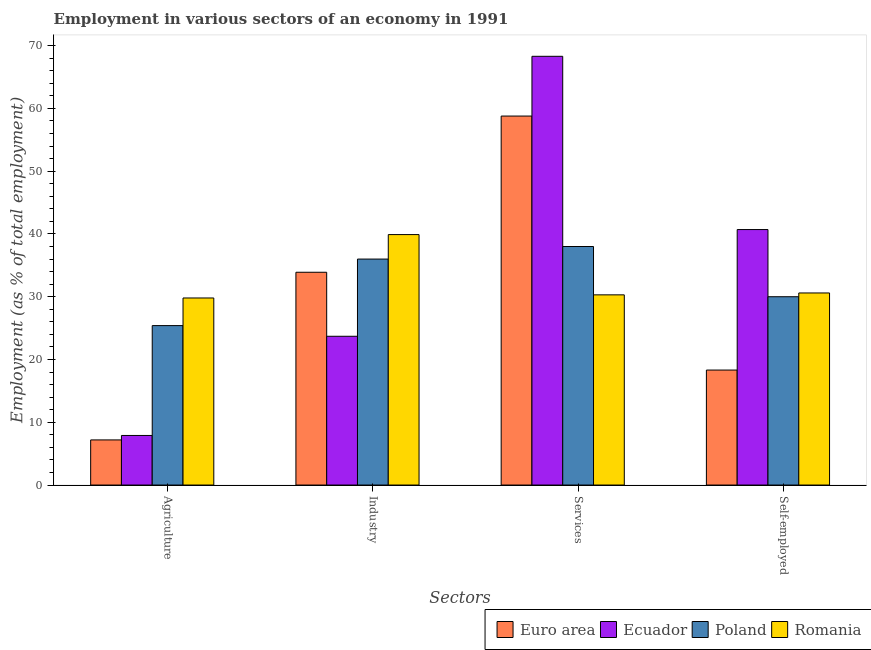Are the number of bars per tick equal to the number of legend labels?
Offer a terse response. Yes. How many bars are there on the 3rd tick from the right?
Keep it short and to the point. 4. What is the label of the 4th group of bars from the left?
Keep it short and to the point. Self-employed. Across all countries, what is the maximum percentage of workers in industry?
Keep it short and to the point. 39.9. Across all countries, what is the minimum percentage of workers in industry?
Provide a short and direct response. 23.7. In which country was the percentage of workers in industry maximum?
Give a very brief answer. Romania. What is the total percentage of workers in industry in the graph?
Keep it short and to the point. 133.5. What is the difference between the percentage of workers in industry in Romania and that in Poland?
Provide a short and direct response. 3.9. What is the difference between the percentage of workers in agriculture in Euro area and the percentage of workers in services in Romania?
Provide a succinct answer. -23.11. What is the average percentage of workers in services per country?
Make the answer very short. 48.85. What is the difference between the percentage of workers in services and percentage of workers in industry in Romania?
Your answer should be very brief. -9.6. In how many countries, is the percentage of self employed workers greater than 44 %?
Make the answer very short. 0. What is the ratio of the percentage of workers in services in Romania to that in Ecuador?
Provide a short and direct response. 0.44. Is the difference between the percentage of workers in services in Poland and Ecuador greater than the difference between the percentage of workers in agriculture in Poland and Ecuador?
Keep it short and to the point. No. What is the difference between the highest and the second highest percentage of workers in industry?
Provide a succinct answer. 3.9. What is the difference between the highest and the lowest percentage of self employed workers?
Your answer should be very brief. 22.38. In how many countries, is the percentage of workers in agriculture greater than the average percentage of workers in agriculture taken over all countries?
Provide a succinct answer. 2. Is the sum of the percentage of workers in agriculture in Euro area and Poland greater than the maximum percentage of workers in industry across all countries?
Your response must be concise. No. What does the 1st bar from the left in Industry represents?
Your answer should be compact. Euro area. What does the 2nd bar from the right in Services represents?
Your answer should be compact. Poland. Is it the case that in every country, the sum of the percentage of workers in agriculture and percentage of workers in industry is greater than the percentage of workers in services?
Keep it short and to the point. No. What is the difference between two consecutive major ticks on the Y-axis?
Provide a succinct answer. 10. Are the values on the major ticks of Y-axis written in scientific E-notation?
Keep it short and to the point. No. Does the graph contain grids?
Your answer should be compact. No. Where does the legend appear in the graph?
Your answer should be very brief. Bottom right. How are the legend labels stacked?
Provide a short and direct response. Horizontal. What is the title of the graph?
Offer a terse response. Employment in various sectors of an economy in 1991. Does "Fragile and conflict affected situations" appear as one of the legend labels in the graph?
Offer a very short reply. No. What is the label or title of the X-axis?
Offer a very short reply. Sectors. What is the label or title of the Y-axis?
Ensure brevity in your answer.  Employment (as % of total employment). What is the Employment (as % of total employment) of Euro area in Agriculture?
Keep it short and to the point. 7.19. What is the Employment (as % of total employment) in Ecuador in Agriculture?
Your answer should be very brief. 7.9. What is the Employment (as % of total employment) in Poland in Agriculture?
Provide a succinct answer. 25.4. What is the Employment (as % of total employment) in Romania in Agriculture?
Offer a terse response. 29.8. What is the Employment (as % of total employment) of Euro area in Industry?
Your answer should be compact. 33.9. What is the Employment (as % of total employment) of Ecuador in Industry?
Provide a short and direct response. 23.7. What is the Employment (as % of total employment) in Romania in Industry?
Keep it short and to the point. 39.9. What is the Employment (as % of total employment) of Euro area in Services?
Make the answer very short. 58.78. What is the Employment (as % of total employment) in Ecuador in Services?
Make the answer very short. 68.3. What is the Employment (as % of total employment) in Romania in Services?
Your answer should be very brief. 30.3. What is the Employment (as % of total employment) in Euro area in Self-employed?
Your answer should be very brief. 18.32. What is the Employment (as % of total employment) of Ecuador in Self-employed?
Provide a succinct answer. 40.7. What is the Employment (as % of total employment) of Poland in Self-employed?
Offer a very short reply. 30. What is the Employment (as % of total employment) in Romania in Self-employed?
Offer a very short reply. 30.6. Across all Sectors, what is the maximum Employment (as % of total employment) in Euro area?
Ensure brevity in your answer.  58.78. Across all Sectors, what is the maximum Employment (as % of total employment) of Ecuador?
Provide a succinct answer. 68.3. Across all Sectors, what is the maximum Employment (as % of total employment) of Poland?
Offer a very short reply. 38. Across all Sectors, what is the maximum Employment (as % of total employment) in Romania?
Provide a short and direct response. 39.9. Across all Sectors, what is the minimum Employment (as % of total employment) of Euro area?
Provide a succinct answer. 7.19. Across all Sectors, what is the minimum Employment (as % of total employment) of Ecuador?
Give a very brief answer. 7.9. Across all Sectors, what is the minimum Employment (as % of total employment) of Poland?
Provide a succinct answer. 25.4. Across all Sectors, what is the minimum Employment (as % of total employment) in Romania?
Your answer should be compact. 29.8. What is the total Employment (as % of total employment) of Euro area in the graph?
Provide a short and direct response. 118.19. What is the total Employment (as % of total employment) in Ecuador in the graph?
Your answer should be very brief. 140.6. What is the total Employment (as % of total employment) in Poland in the graph?
Make the answer very short. 129.4. What is the total Employment (as % of total employment) in Romania in the graph?
Give a very brief answer. 130.6. What is the difference between the Employment (as % of total employment) of Euro area in Agriculture and that in Industry?
Your answer should be very brief. -26.71. What is the difference between the Employment (as % of total employment) of Ecuador in Agriculture and that in Industry?
Your answer should be very brief. -15.8. What is the difference between the Employment (as % of total employment) of Poland in Agriculture and that in Industry?
Make the answer very short. -10.6. What is the difference between the Employment (as % of total employment) of Romania in Agriculture and that in Industry?
Provide a succinct answer. -10.1. What is the difference between the Employment (as % of total employment) in Euro area in Agriculture and that in Services?
Offer a very short reply. -51.59. What is the difference between the Employment (as % of total employment) in Ecuador in Agriculture and that in Services?
Keep it short and to the point. -60.4. What is the difference between the Employment (as % of total employment) in Euro area in Agriculture and that in Self-employed?
Provide a short and direct response. -11.13. What is the difference between the Employment (as % of total employment) of Ecuador in Agriculture and that in Self-employed?
Keep it short and to the point. -32.8. What is the difference between the Employment (as % of total employment) of Poland in Agriculture and that in Self-employed?
Offer a terse response. -4.6. What is the difference between the Employment (as % of total employment) of Romania in Agriculture and that in Self-employed?
Give a very brief answer. -0.8. What is the difference between the Employment (as % of total employment) in Euro area in Industry and that in Services?
Your answer should be very brief. -24.88. What is the difference between the Employment (as % of total employment) of Ecuador in Industry and that in Services?
Ensure brevity in your answer.  -44.6. What is the difference between the Employment (as % of total employment) in Poland in Industry and that in Services?
Provide a succinct answer. -2. What is the difference between the Employment (as % of total employment) of Romania in Industry and that in Services?
Provide a succinct answer. 9.6. What is the difference between the Employment (as % of total employment) of Euro area in Industry and that in Self-employed?
Give a very brief answer. 15.58. What is the difference between the Employment (as % of total employment) in Euro area in Services and that in Self-employed?
Give a very brief answer. 40.46. What is the difference between the Employment (as % of total employment) in Ecuador in Services and that in Self-employed?
Your response must be concise. 27.6. What is the difference between the Employment (as % of total employment) in Euro area in Agriculture and the Employment (as % of total employment) in Ecuador in Industry?
Offer a very short reply. -16.51. What is the difference between the Employment (as % of total employment) of Euro area in Agriculture and the Employment (as % of total employment) of Poland in Industry?
Offer a very short reply. -28.81. What is the difference between the Employment (as % of total employment) in Euro area in Agriculture and the Employment (as % of total employment) in Romania in Industry?
Offer a terse response. -32.71. What is the difference between the Employment (as % of total employment) of Ecuador in Agriculture and the Employment (as % of total employment) of Poland in Industry?
Your answer should be compact. -28.1. What is the difference between the Employment (as % of total employment) of Ecuador in Agriculture and the Employment (as % of total employment) of Romania in Industry?
Provide a succinct answer. -32. What is the difference between the Employment (as % of total employment) in Euro area in Agriculture and the Employment (as % of total employment) in Ecuador in Services?
Your response must be concise. -61.11. What is the difference between the Employment (as % of total employment) in Euro area in Agriculture and the Employment (as % of total employment) in Poland in Services?
Ensure brevity in your answer.  -30.81. What is the difference between the Employment (as % of total employment) in Euro area in Agriculture and the Employment (as % of total employment) in Romania in Services?
Offer a very short reply. -23.11. What is the difference between the Employment (as % of total employment) in Ecuador in Agriculture and the Employment (as % of total employment) in Poland in Services?
Make the answer very short. -30.1. What is the difference between the Employment (as % of total employment) of Ecuador in Agriculture and the Employment (as % of total employment) of Romania in Services?
Make the answer very short. -22.4. What is the difference between the Employment (as % of total employment) of Poland in Agriculture and the Employment (as % of total employment) of Romania in Services?
Provide a succinct answer. -4.9. What is the difference between the Employment (as % of total employment) in Euro area in Agriculture and the Employment (as % of total employment) in Ecuador in Self-employed?
Provide a succinct answer. -33.51. What is the difference between the Employment (as % of total employment) in Euro area in Agriculture and the Employment (as % of total employment) in Poland in Self-employed?
Give a very brief answer. -22.81. What is the difference between the Employment (as % of total employment) in Euro area in Agriculture and the Employment (as % of total employment) in Romania in Self-employed?
Your answer should be very brief. -23.41. What is the difference between the Employment (as % of total employment) in Ecuador in Agriculture and the Employment (as % of total employment) in Poland in Self-employed?
Offer a very short reply. -22.1. What is the difference between the Employment (as % of total employment) in Ecuador in Agriculture and the Employment (as % of total employment) in Romania in Self-employed?
Make the answer very short. -22.7. What is the difference between the Employment (as % of total employment) in Poland in Agriculture and the Employment (as % of total employment) in Romania in Self-employed?
Give a very brief answer. -5.2. What is the difference between the Employment (as % of total employment) in Euro area in Industry and the Employment (as % of total employment) in Ecuador in Services?
Your answer should be very brief. -34.4. What is the difference between the Employment (as % of total employment) of Euro area in Industry and the Employment (as % of total employment) of Poland in Services?
Keep it short and to the point. -4.1. What is the difference between the Employment (as % of total employment) of Euro area in Industry and the Employment (as % of total employment) of Romania in Services?
Offer a very short reply. 3.6. What is the difference between the Employment (as % of total employment) in Ecuador in Industry and the Employment (as % of total employment) in Poland in Services?
Give a very brief answer. -14.3. What is the difference between the Employment (as % of total employment) of Ecuador in Industry and the Employment (as % of total employment) of Romania in Services?
Make the answer very short. -6.6. What is the difference between the Employment (as % of total employment) in Poland in Industry and the Employment (as % of total employment) in Romania in Services?
Provide a succinct answer. 5.7. What is the difference between the Employment (as % of total employment) of Euro area in Industry and the Employment (as % of total employment) of Ecuador in Self-employed?
Provide a succinct answer. -6.8. What is the difference between the Employment (as % of total employment) in Euro area in Industry and the Employment (as % of total employment) in Poland in Self-employed?
Your response must be concise. 3.9. What is the difference between the Employment (as % of total employment) of Euro area in Industry and the Employment (as % of total employment) of Romania in Self-employed?
Keep it short and to the point. 3.3. What is the difference between the Employment (as % of total employment) in Ecuador in Industry and the Employment (as % of total employment) in Poland in Self-employed?
Keep it short and to the point. -6.3. What is the difference between the Employment (as % of total employment) of Ecuador in Industry and the Employment (as % of total employment) of Romania in Self-employed?
Keep it short and to the point. -6.9. What is the difference between the Employment (as % of total employment) of Poland in Industry and the Employment (as % of total employment) of Romania in Self-employed?
Offer a terse response. 5.4. What is the difference between the Employment (as % of total employment) in Euro area in Services and the Employment (as % of total employment) in Ecuador in Self-employed?
Give a very brief answer. 18.08. What is the difference between the Employment (as % of total employment) in Euro area in Services and the Employment (as % of total employment) in Poland in Self-employed?
Offer a terse response. 28.78. What is the difference between the Employment (as % of total employment) in Euro area in Services and the Employment (as % of total employment) in Romania in Self-employed?
Make the answer very short. 28.18. What is the difference between the Employment (as % of total employment) of Ecuador in Services and the Employment (as % of total employment) of Poland in Self-employed?
Keep it short and to the point. 38.3. What is the difference between the Employment (as % of total employment) of Ecuador in Services and the Employment (as % of total employment) of Romania in Self-employed?
Your response must be concise. 37.7. What is the difference between the Employment (as % of total employment) of Poland in Services and the Employment (as % of total employment) of Romania in Self-employed?
Make the answer very short. 7.4. What is the average Employment (as % of total employment) in Euro area per Sectors?
Your answer should be very brief. 29.55. What is the average Employment (as % of total employment) in Ecuador per Sectors?
Your response must be concise. 35.15. What is the average Employment (as % of total employment) in Poland per Sectors?
Ensure brevity in your answer.  32.35. What is the average Employment (as % of total employment) of Romania per Sectors?
Your answer should be compact. 32.65. What is the difference between the Employment (as % of total employment) of Euro area and Employment (as % of total employment) of Ecuador in Agriculture?
Offer a terse response. -0.71. What is the difference between the Employment (as % of total employment) of Euro area and Employment (as % of total employment) of Poland in Agriculture?
Offer a terse response. -18.21. What is the difference between the Employment (as % of total employment) in Euro area and Employment (as % of total employment) in Romania in Agriculture?
Give a very brief answer. -22.61. What is the difference between the Employment (as % of total employment) of Ecuador and Employment (as % of total employment) of Poland in Agriculture?
Provide a short and direct response. -17.5. What is the difference between the Employment (as % of total employment) of Ecuador and Employment (as % of total employment) of Romania in Agriculture?
Offer a terse response. -21.9. What is the difference between the Employment (as % of total employment) of Euro area and Employment (as % of total employment) of Ecuador in Industry?
Offer a very short reply. 10.2. What is the difference between the Employment (as % of total employment) in Euro area and Employment (as % of total employment) in Poland in Industry?
Keep it short and to the point. -2.1. What is the difference between the Employment (as % of total employment) of Euro area and Employment (as % of total employment) of Romania in Industry?
Keep it short and to the point. -6. What is the difference between the Employment (as % of total employment) in Ecuador and Employment (as % of total employment) in Poland in Industry?
Give a very brief answer. -12.3. What is the difference between the Employment (as % of total employment) of Ecuador and Employment (as % of total employment) of Romania in Industry?
Give a very brief answer. -16.2. What is the difference between the Employment (as % of total employment) in Euro area and Employment (as % of total employment) in Ecuador in Services?
Offer a very short reply. -9.52. What is the difference between the Employment (as % of total employment) in Euro area and Employment (as % of total employment) in Poland in Services?
Provide a short and direct response. 20.78. What is the difference between the Employment (as % of total employment) in Euro area and Employment (as % of total employment) in Romania in Services?
Your answer should be very brief. 28.48. What is the difference between the Employment (as % of total employment) of Ecuador and Employment (as % of total employment) of Poland in Services?
Give a very brief answer. 30.3. What is the difference between the Employment (as % of total employment) in Euro area and Employment (as % of total employment) in Ecuador in Self-employed?
Provide a short and direct response. -22.38. What is the difference between the Employment (as % of total employment) in Euro area and Employment (as % of total employment) in Poland in Self-employed?
Your answer should be compact. -11.68. What is the difference between the Employment (as % of total employment) in Euro area and Employment (as % of total employment) in Romania in Self-employed?
Provide a short and direct response. -12.28. What is the ratio of the Employment (as % of total employment) in Euro area in Agriculture to that in Industry?
Provide a succinct answer. 0.21. What is the ratio of the Employment (as % of total employment) of Poland in Agriculture to that in Industry?
Your response must be concise. 0.71. What is the ratio of the Employment (as % of total employment) in Romania in Agriculture to that in Industry?
Keep it short and to the point. 0.75. What is the ratio of the Employment (as % of total employment) of Euro area in Agriculture to that in Services?
Offer a very short reply. 0.12. What is the ratio of the Employment (as % of total employment) in Ecuador in Agriculture to that in Services?
Offer a terse response. 0.12. What is the ratio of the Employment (as % of total employment) in Poland in Agriculture to that in Services?
Offer a very short reply. 0.67. What is the ratio of the Employment (as % of total employment) in Romania in Agriculture to that in Services?
Your answer should be very brief. 0.98. What is the ratio of the Employment (as % of total employment) of Euro area in Agriculture to that in Self-employed?
Your response must be concise. 0.39. What is the ratio of the Employment (as % of total employment) in Ecuador in Agriculture to that in Self-employed?
Your answer should be compact. 0.19. What is the ratio of the Employment (as % of total employment) of Poland in Agriculture to that in Self-employed?
Your response must be concise. 0.85. What is the ratio of the Employment (as % of total employment) in Romania in Agriculture to that in Self-employed?
Make the answer very short. 0.97. What is the ratio of the Employment (as % of total employment) in Euro area in Industry to that in Services?
Your answer should be compact. 0.58. What is the ratio of the Employment (as % of total employment) of Ecuador in Industry to that in Services?
Your response must be concise. 0.35. What is the ratio of the Employment (as % of total employment) in Romania in Industry to that in Services?
Your answer should be very brief. 1.32. What is the ratio of the Employment (as % of total employment) of Euro area in Industry to that in Self-employed?
Offer a terse response. 1.85. What is the ratio of the Employment (as % of total employment) in Ecuador in Industry to that in Self-employed?
Provide a short and direct response. 0.58. What is the ratio of the Employment (as % of total employment) of Romania in Industry to that in Self-employed?
Keep it short and to the point. 1.3. What is the ratio of the Employment (as % of total employment) of Euro area in Services to that in Self-employed?
Offer a terse response. 3.21. What is the ratio of the Employment (as % of total employment) in Ecuador in Services to that in Self-employed?
Offer a terse response. 1.68. What is the ratio of the Employment (as % of total employment) in Poland in Services to that in Self-employed?
Provide a short and direct response. 1.27. What is the ratio of the Employment (as % of total employment) of Romania in Services to that in Self-employed?
Offer a terse response. 0.99. What is the difference between the highest and the second highest Employment (as % of total employment) of Euro area?
Offer a terse response. 24.88. What is the difference between the highest and the second highest Employment (as % of total employment) of Ecuador?
Ensure brevity in your answer.  27.6. What is the difference between the highest and the second highest Employment (as % of total employment) in Poland?
Keep it short and to the point. 2. What is the difference between the highest and the second highest Employment (as % of total employment) of Romania?
Keep it short and to the point. 9.3. What is the difference between the highest and the lowest Employment (as % of total employment) of Euro area?
Make the answer very short. 51.59. What is the difference between the highest and the lowest Employment (as % of total employment) in Ecuador?
Offer a very short reply. 60.4. 